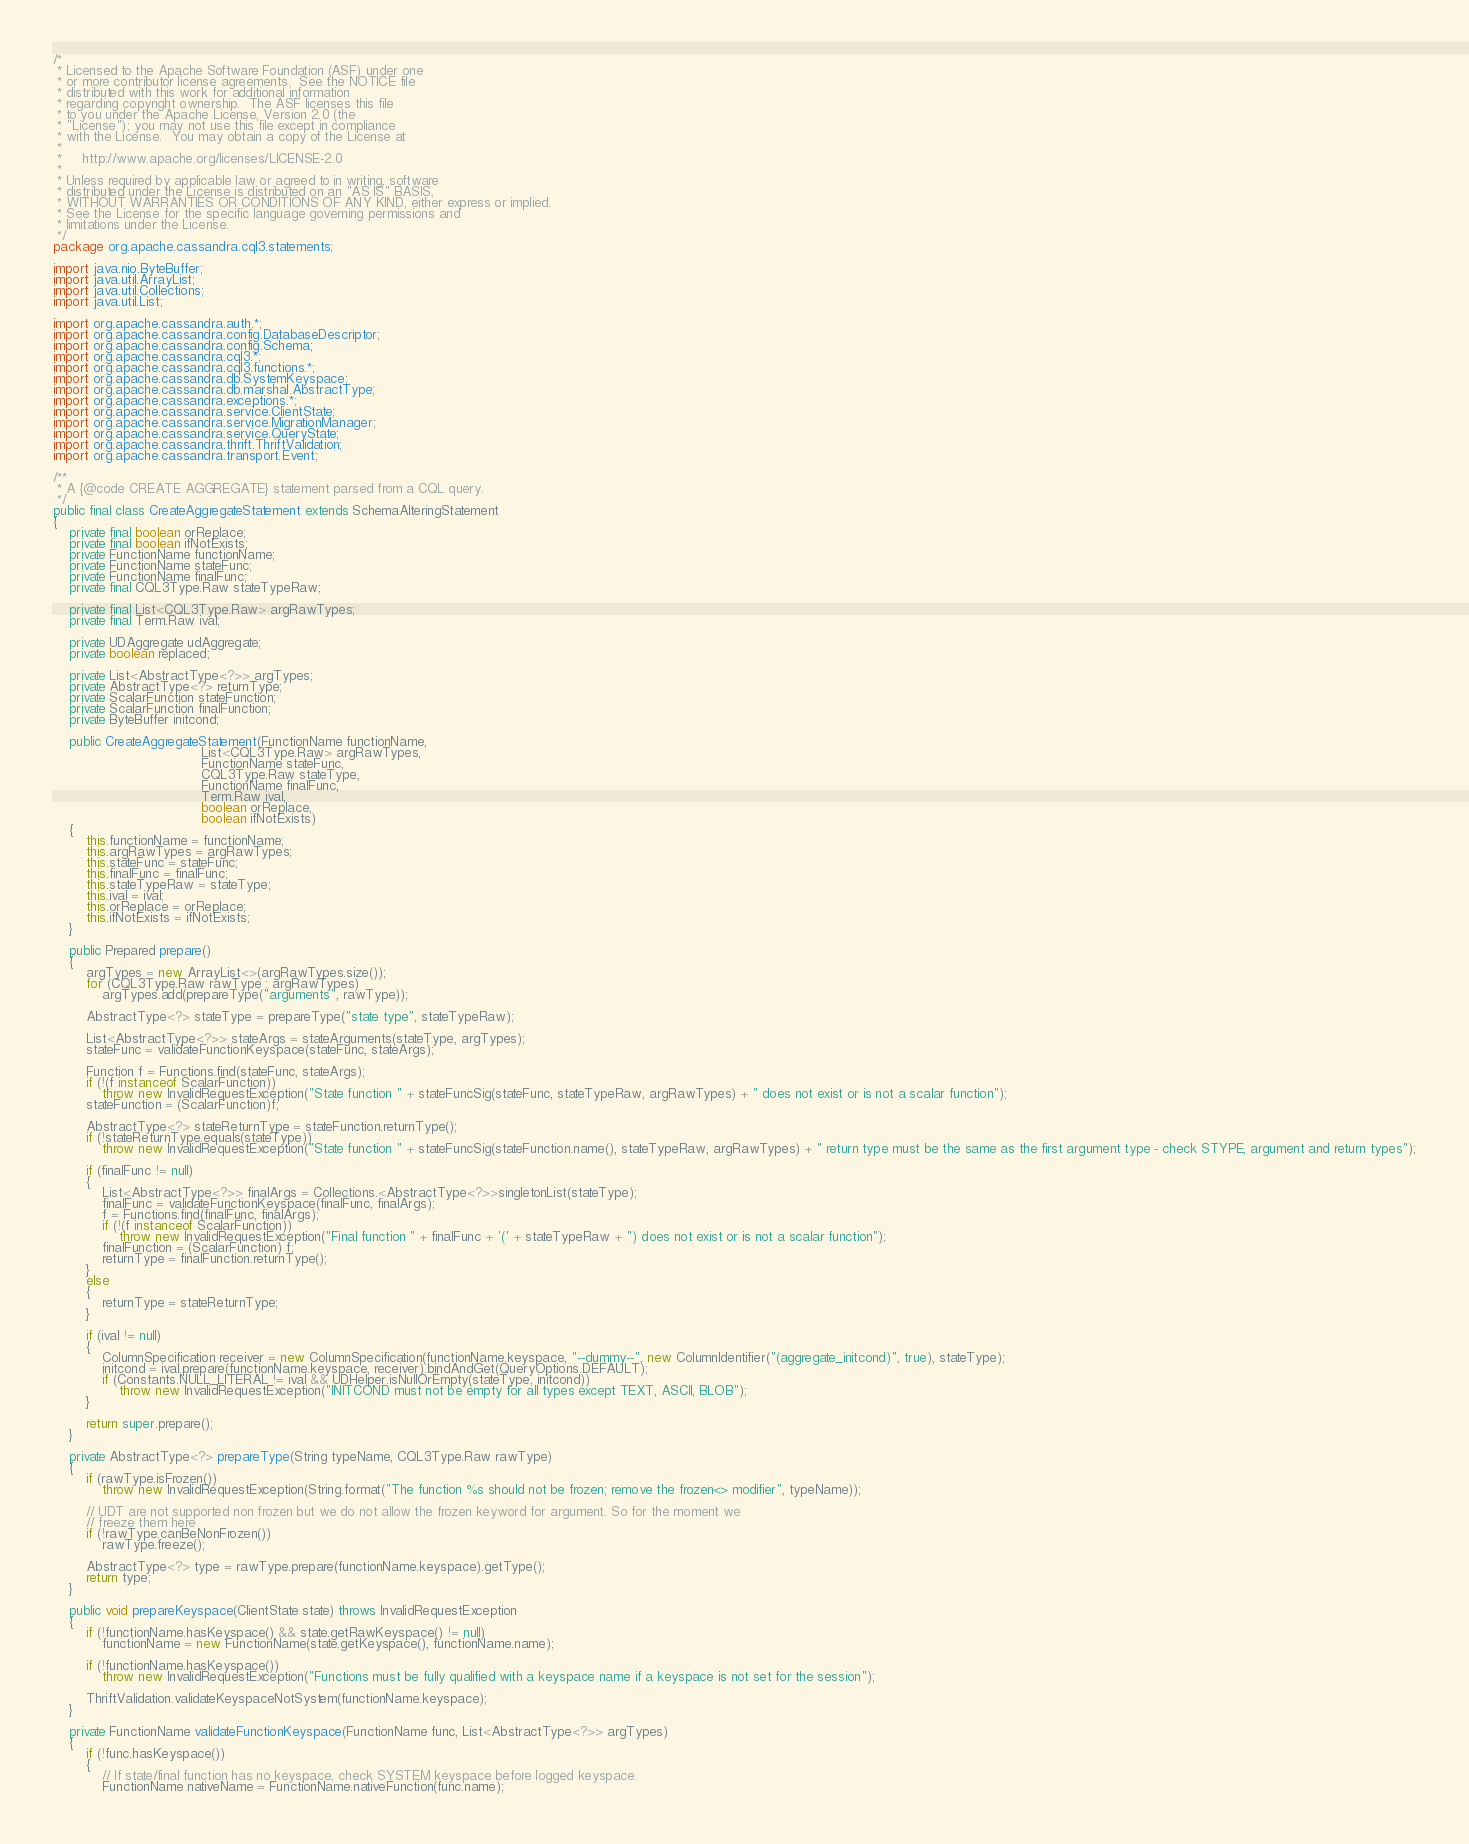Convert code to text. <code><loc_0><loc_0><loc_500><loc_500><_Java_>/*
 * Licensed to the Apache Software Foundation (ASF) under one
 * or more contributor license agreements.  See the NOTICE file
 * distributed with this work for additional information
 * regarding copyright ownership.  The ASF licenses this file
 * to you under the Apache License, Version 2.0 (the
 * "License"); you may not use this file except in compliance
 * with the License.  You may obtain a copy of the License at
 *
 *     http://www.apache.org/licenses/LICENSE-2.0
 *
 * Unless required by applicable law or agreed to in writing, software
 * distributed under the License is distributed on an "AS IS" BASIS,
 * WITHOUT WARRANTIES OR CONDITIONS OF ANY KIND, either express or implied.
 * See the License for the specific language governing permissions and
 * limitations under the License.
 */
package org.apache.cassandra.cql3.statements;

import java.nio.ByteBuffer;
import java.util.ArrayList;
import java.util.Collections;
import java.util.List;

import org.apache.cassandra.auth.*;
import org.apache.cassandra.config.DatabaseDescriptor;
import org.apache.cassandra.config.Schema;
import org.apache.cassandra.cql3.*;
import org.apache.cassandra.cql3.functions.*;
import org.apache.cassandra.db.SystemKeyspace;
import org.apache.cassandra.db.marshal.AbstractType;
import org.apache.cassandra.exceptions.*;
import org.apache.cassandra.service.ClientState;
import org.apache.cassandra.service.MigrationManager;
import org.apache.cassandra.service.QueryState;
import org.apache.cassandra.thrift.ThriftValidation;
import org.apache.cassandra.transport.Event;

/**
 * A {@code CREATE AGGREGATE} statement parsed from a CQL query.
 */
public final class CreateAggregateStatement extends SchemaAlteringStatement
{
    private final boolean orReplace;
    private final boolean ifNotExists;
    private FunctionName functionName;
    private FunctionName stateFunc;
    private FunctionName finalFunc;
    private final CQL3Type.Raw stateTypeRaw;

    private final List<CQL3Type.Raw> argRawTypes;
    private final Term.Raw ival;

    private UDAggregate udAggregate;
    private boolean replaced;

    private List<AbstractType<?>> argTypes;
    private AbstractType<?> returnType;
    private ScalarFunction stateFunction;
    private ScalarFunction finalFunction;
    private ByteBuffer initcond;

    public CreateAggregateStatement(FunctionName functionName,
                                    List<CQL3Type.Raw> argRawTypes,
                                    FunctionName stateFunc,
                                    CQL3Type.Raw stateType,
                                    FunctionName finalFunc,
                                    Term.Raw ival,
                                    boolean orReplace,
                                    boolean ifNotExists)
    {
        this.functionName = functionName;
        this.argRawTypes = argRawTypes;
        this.stateFunc = stateFunc;
        this.finalFunc = finalFunc;
        this.stateTypeRaw = stateType;
        this.ival = ival;
        this.orReplace = orReplace;
        this.ifNotExists = ifNotExists;
    }

    public Prepared prepare()
    {
        argTypes = new ArrayList<>(argRawTypes.size());
        for (CQL3Type.Raw rawType : argRawTypes)
            argTypes.add(prepareType("arguments", rawType));

        AbstractType<?> stateType = prepareType("state type", stateTypeRaw);

        List<AbstractType<?>> stateArgs = stateArguments(stateType, argTypes);
        stateFunc = validateFunctionKeyspace(stateFunc, stateArgs);

        Function f = Functions.find(stateFunc, stateArgs);
        if (!(f instanceof ScalarFunction))
            throw new InvalidRequestException("State function " + stateFuncSig(stateFunc, stateTypeRaw, argRawTypes) + " does not exist or is not a scalar function");
        stateFunction = (ScalarFunction)f;

        AbstractType<?> stateReturnType = stateFunction.returnType();
        if (!stateReturnType.equals(stateType))
            throw new InvalidRequestException("State function " + stateFuncSig(stateFunction.name(), stateTypeRaw, argRawTypes) + " return type must be the same as the first argument type - check STYPE, argument and return types");

        if (finalFunc != null)
        {
            List<AbstractType<?>> finalArgs = Collections.<AbstractType<?>>singletonList(stateType);
            finalFunc = validateFunctionKeyspace(finalFunc, finalArgs);
            f = Functions.find(finalFunc, finalArgs);
            if (!(f instanceof ScalarFunction))
                throw new InvalidRequestException("Final function " + finalFunc + '(' + stateTypeRaw + ") does not exist or is not a scalar function");
            finalFunction = (ScalarFunction) f;
            returnType = finalFunction.returnType();
        }
        else
        {
            returnType = stateReturnType;
        }

        if (ival != null)
        {
            ColumnSpecification receiver = new ColumnSpecification(functionName.keyspace, "--dummy--", new ColumnIdentifier("(aggregate_initcond)", true), stateType);
            initcond = ival.prepare(functionName.keyspace, receiver).bindAndGet(QueryOptions.DEFAULT);
            if (Constants.NULL_LITERAL != ival && UDHelper.isNullOrEmpty(stateType, initcond))
                throw new InvalidRequestException("INITCOND must not be empty for all types except TEXT, ASCII, BLOB");
        }

        return super.prepare();
    }

    private AbstractType<?> prepareType(String typeName, CQL3Type.Raw rawType)
    {
        if (rawType.isFrozen())
            throw new InvalidRequestException(String.format("The function %s should not be frozen; remove the frozen<> modifier", typeName));

        // UDT are not supported non frozen but we do not allow the frozen keyword for argument. So for the moment we
        // freeze them here
        if (!rawType.canBeNonFrozen())
            rawType.freeze();

        AbstractType<?> type = rawType.prepare(functionName.keyspace).getType();
        return type;
    }

    public void prepareKeyspace(ClientState state) throws InvalidRequestException
    {
        if (!functionName.hasKeyspace() && state.getRawKeyspace() != null)
            functionName = new FunctionName(state.getKeyspace(), functionName.name);

        if (!functionName.hasKeyspace())
            throw new InvalidRequestException("Functions must be fully qualified with a keyspace name if a keyspace is not set for the session");

        ThriftValidation.validateKeyspaceNotSystem(functionName.keyspace);
    }

    private FunctionName validateFunctionKeyspace(FunctionName func, List<AbstractType<?>> argTypes)
    {
        if (!func.hasKeyspace())
        {
            // If state/final function has no keyspace, check SYSTEM keyspace before logged keyspace.
            FunctionName nativeName = FunctionName.nativeFunction(func.name);</code> 